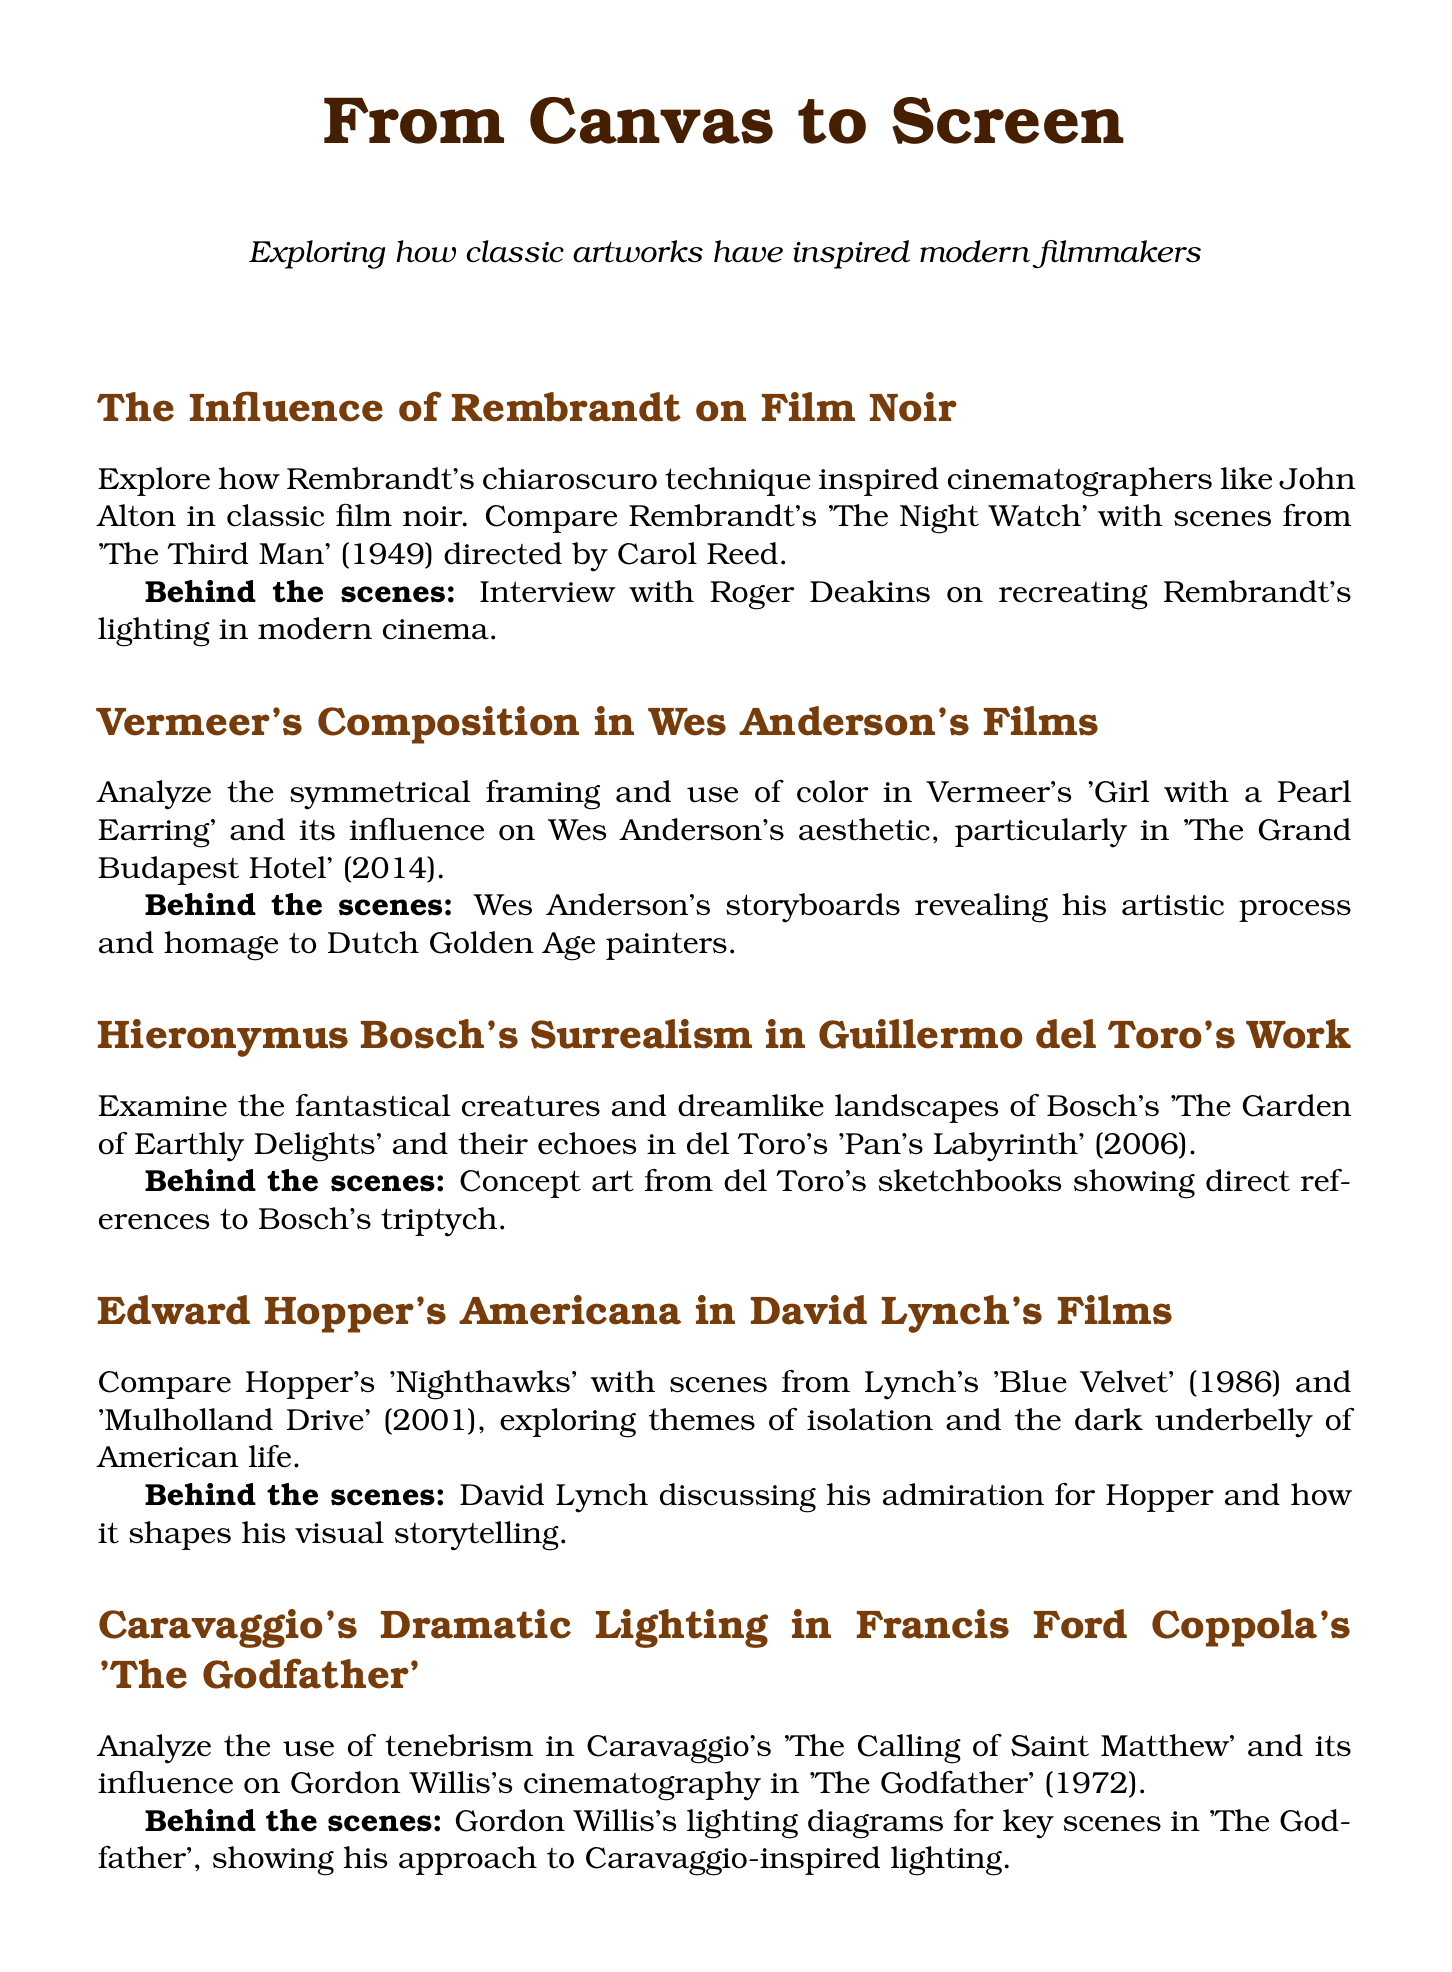What is the title of the newsletter? The title is stated at the beginning, summarizing the focus on artworks and filmmakers.
Answer: From Canvas to Screen Which filmmaker directed 'The Third Man'? The newsletter mentions that Carol Reed is the director of this film, highlighted in the section on Rembrandt's influence.
Answer: Carol Reed What is the featured work at the Rijksmuseum? The document specifies that Rembrandt's 'The Night Watch' is featured at this museum.
Answer: The Night Watch by Rembrandt Who is interviewed regarding lighting inspired by Rembrandt? The behind-the-scenes section for Rembrandt's influence notes an interview with a specific cinematographer.
Answer: Roger Deakins What painting is analyzed in relation to Wes Anderson's films? The section discusses the influence of a particular painting on Anderson's aesthetic.
Answer: Girl with a Pearl Earring Which artist's work is compared with Guillermo del Toro's 'Pan's Labyrinth'? The document highlights a specific artist whose surrealism echoes in del Toro's film.
Answer: Hieronymus Bosch What theme is explored in David Lynch's films? The content provides insights into recurring themes in Lynch's work, specifically his connection to another artist.
Answer: Isolation How many featured directors are listed in the newsletter? The list of highlighted directors counts how many are mentioned in the document.
Answer: Six What is the name of the film discussed alongside Caravaggio's work? The document specifies the film that notably draws inspiration from Caravaggio's painting technique.
Answer: The Godfather In which city is the Belvedere Museum located? The newsletter indicates the location of this museum by mentioning the specific city.
Answer: Vienna 